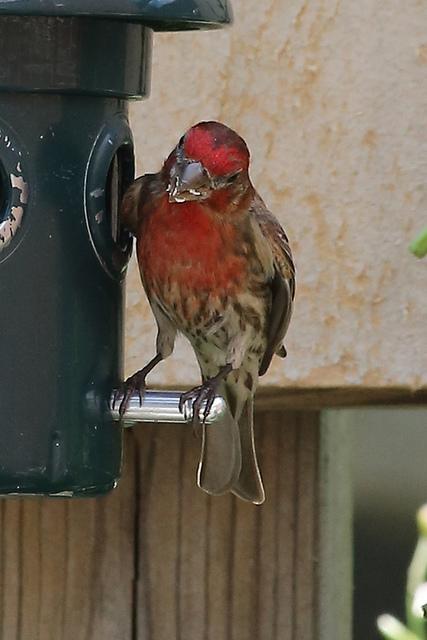What type of bird is on the feeder?
Be succinct. Robin. What color is the bird?
Write a very short answer. Red and brown. What color is the perch?
Give a very brief answer. Silver. 